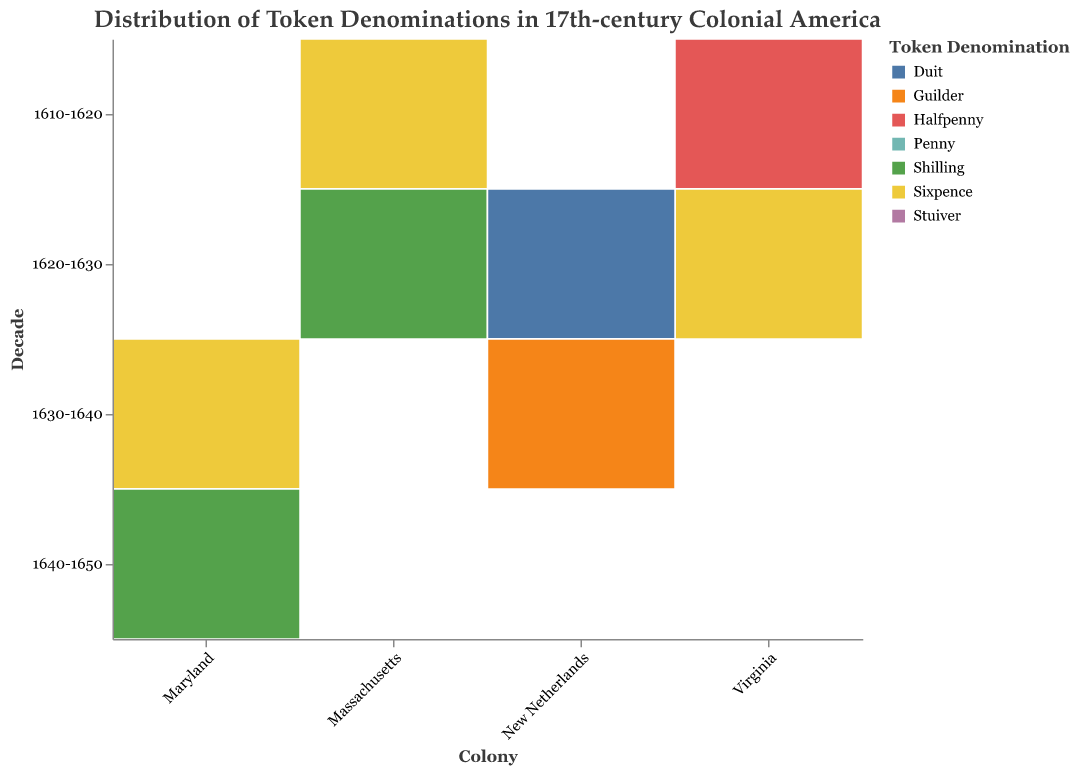What is the most common token denomination in Massachusetts between 1610-1620? Look at the plots for Massachusetts in the 1610-1620 block. The Penny denomination has the largest area compared to the Sixpence denomination.
Answer: Penny Which colony had the highest frequency of Penny tokens in any given decade? Compare the sizes of the blocks for the Penny category across all colonies and decades. Massachusetts in the 1620-1630 decade has the largest block for Penny tokens.
Answer: Massachusetts in 1620-1630 How many different denominations of tokens were used in Virginia between 1620-1630? Observe the color segments within the Virginia section for the 1620-1630 decade. There are segments for Penny, Halfpenny, and Sixpence.
Answer: Three In which decade did Maryland have the highest overall token usage? Look at all decades for Maryland and compare the total area of all colored blocks combined. The 1640-1650 decade has the largest combined area.
Answer: 1640-1650 How does the frequency of the Stuiver denomination in New Netherlands in the 1620-1630 decade compare to the 1630-1640 decade? Compare the size of the Stuiver blocks in the 1620-1630 and 1630-1640 decade sections for New Netherlands. The block is larger in 1630-1640.
Answer: Higher in 1630-1640 Which colony introduced the Shilling denomination first? Identify the earliest decade in which any colony is associated with the Shilling denomination. Massachusetts in 1620-1630 is the first instance.
Answer: Massachusetts Between 1610-1620 and 1620-1630, how did the frequency of Sixpence tokens change in Massachusetts? Compare the Sixpence blocks for Massachusetts in 1610-1620 and 1620-1630. The block increases from 30 to 40.
Answer: Increased by 10 How many colonies are shown on the plot? Count the number of distinct labels on the x-axis, representing colonies. Massachusetts, Virginia, New Netherlands, and Maryland are shown.
Answer: Four Which colony had the least diverse token usage in terms of the number of different denominations between 1630-1640? For each colony in the 1630-1640 decade, count the number of different token denominations. Maryland has Penny and Sixpence, while New Netherlands has Stuiver, Duit, and Guilder.
Answer: Maryland How did the usage of the Halfpenny denomination change in Virginia from 1610-1620 to 1620-1630? Compare the Halfpenny blocks in Virginia for 1610-1620 and 1620-1630. The block increases from 20 to 30.
Answer: Increased by 10 